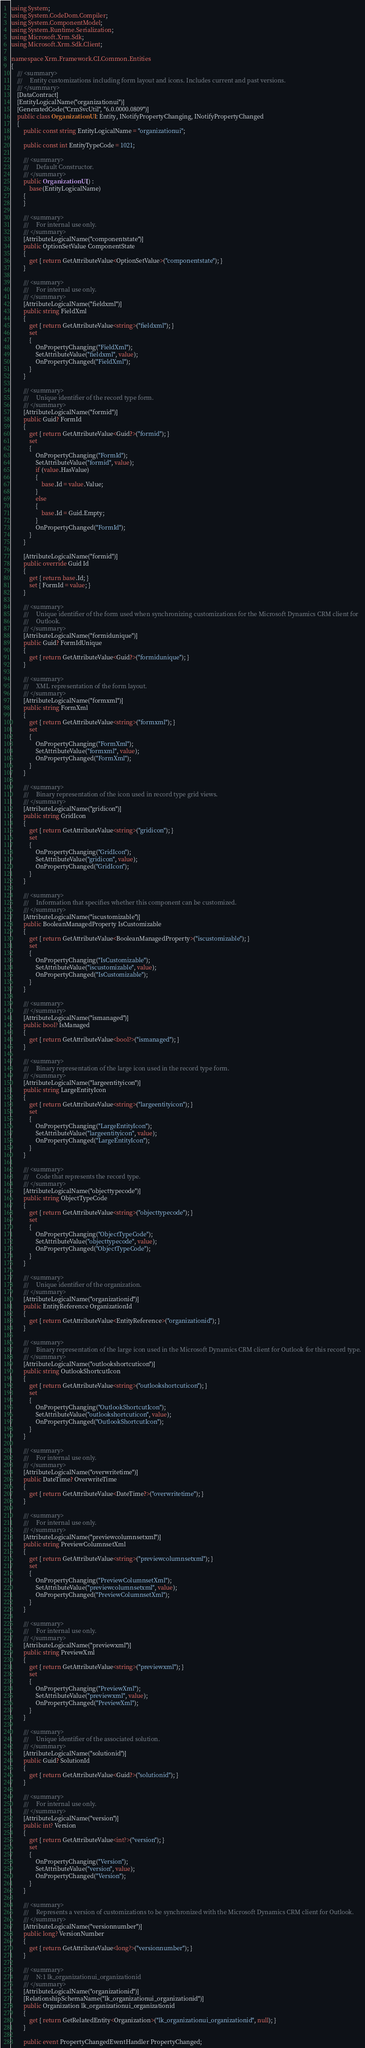<code> <loc_0><loc_0><loc_500><loc_500><_C#_>using System;
using System.CodeDom.Compiler;
using System.ComponentModel;
using System.Runtime.Serialization;
using Microsoft.Xrm.Sdk;
using Microsoft.Xrm.Sdk.Client;

namespace Xrm.Framework.CI.Common.Entities
{
    /// <summary>
    ///     Entity customizations including form layout and icons. Includes current and past versions.
    /// </summary>
    [DataContract]
    [EntityLogicalName("organizationui")]
    [GeneratedCode("CrmSvcUtil", "6.0.0000.0809")]
    public class OrganizationUI : Entity, INotifyPropertyChanging, INotifyPropertyChanged
    {
        public const string EntityLogicalName = "organizationui";

        public const int EntityTypeCode = 1021;

        /// <summary>
        ///     Default Constructor.
        /// </summary>
        public OrganizationUI() :
            base(EntityLogicalName)
        {
        }

        /// <summary>
        ///     For internal use only.
        /// </summary>
        [AttributeLogicalName("componentstate")]
        public OptionSetValue ComponentState
        {
            get { return GetAttributeValue<OptionSetValue>("componentstate"); }
        }

        /// <summary>
        ///     For internal use only.
        /// </summary>
        [AttributeLogicalName("fieldxml")]
        public string FieldXml
        {
            get { return GetAttributeValue<string>("fieldxml"); }
            set
            {
                OnPropertyChanging("FieldXml");
                SetAttributeValue("fieldxml", value);
                OnPropertyChanged("FieldXml");
            }
        }

        /// <summary>
        ///     Unique identifier of the record type form.
        /// </summary>
        [AttributeLogicalName("formid")]
        public Guid? FormId
        {
            get { return GetAttributeValue<Guid?>("formid"); }
            set
            {
                OnPropertyChanging("FormId");
                SetAttributeValue("formid", value);
                if (value.HasValue)
                {
                    base.Id = value.Value;
                }
                else
                {
                    base.Id = Guid.Empty;
                }
                OnPropertyChanged("FormId");
            }
        }

        [AttributeLogicalName("formid")]
        public override Guid Id
        {
            get { return base.Id; }
            set { FormId = value; }
        }

        /// <summary>
        ///     Unique identifier of the form used when synchronizing customizations for the Microsoft Dynamics CRM client for
        ///     Outlook.
        /// </summary>
        [AttributeLogicalName("formidunique")]
        public Guid? FormIdUnique
        {
            get { return GetAttributeValue<Guid?>("formidunique"); }
        }

        /// <summary>
        ///     XML representation of the form layout.
        /// </summary>
        [AttributeLogicalName("formxml")]
        public string FormXml
        {
            get { return GetAttributeValue<string>("formxml"); }
            set
            {
                OnPropertyChanging("FormXml");
                SetAttributeValue("formxml", value);
                OnPropertyChanged("FormXml");
            }
        }

        /// <summary>
        ///     Binary representation of the icon used in record type grid views.
        /// </summary>
        [AttributeLogicalName("gridicon")]
        public string GridIcon
        {
            get { return GetAttributeValue<string>("gridicon"); }
            set
            {
                OnPropertyChanging("GridIcon");
                SetAttributeValue("gridicon", value);
                OnPropertyChanged("GridIcon");
            }
        }

        /// <summary>
        ///     Information that specifies whether this component can be customized.
        /// </summary>
        [AttributeLogicalName("iscustomizable")]
        public BooleanManagedProperty IsCustomizable
        {
            get { return GetAttributeValue<BooleanManagedProperty>("iscustomizable"); }
            set
            {
                OnPropertyChanging("IsCustomizable");
                SetAttributeValue("iscustomizable", value);
                OnPropertyChanged("IsCustomizable");
            }
        }

        /// <summary>
        /// </summary>
        [AttributeLogicalName("ismanaged")]
        public bool? IsManaged
        {
            get { return GetAttributeValue<bool?>("ismanaged"); }
        }

        /// <summary>
        ///     Binary representation of the large icon used in the record type form.
        /// </summary>
        [AttributeLogicalName("largeentityicon")]
        public string LargeEntityIcon
        {
            get { return GetAttributeValue<string>("largeentityicon"); }
            set
            {
                OnPropertyChanging("LargeEntityIcon");
                SetAttributeValue("largeentityicon", value);
                OnPropertyChanged("LargeEntityIcon");
            }
        }

        /// <summary>
        ///     Code that represents the record type.
        /// </summary>
        [AttributeLogicalName("objecttypecode")]
        public string ObjectTypeCode
        {
            get { return GetAttributeValue<string>("objecttypecode"); }
            set
            {
                OnPropertyChanging("ObjectTypeCode");
                SetAttributeValue("objecttypecode", value);
                OnPropertyChanged("ObjectTypeCode");
            }
        }

        /// <summary>
        ///     Unique identifier of the organization.
        /// </summary>
        [AttributeLogicalName("organizationid")]
        public EntityReference OrganizationId
        {
            get { return GetAttributeValue<EntityReference>("organizationid"); }
        }

        /// <summary>
        ///     Binary representation of the large icon used in the Microsoft Dynamics CRM client for Outlook for this record type.
        /// </summary>
        [AttributeLogicalName("outlookshortcuticon")]
        public string OutlookShortcutIcon
        {
            get { return GetAttributeValue<string>("outlookshortcuticon"); }
            set
            {
                OnPropertyChanging("OutlookShortcutIcon");
                SetAttributeValue("outlookshortcuticon", value);
                OnPropertyChanged("OutlookShortcutIcon");
            }
        }

        /// <summary>
        ///     For internal use only.
        /// </summary>
        [AttributeLogicalName("overwritetime")]
        public DateTime? OverwriteTime
        {
            get { return GetAttributeValue<DateTime?>("overwritetime"); }
        }

        /// <summary>
        ///     For internal use only.
        /// </summary>
        [AttributeLogicalName("previewcolumnsetxml")]
        public string PreviewColumnsetXml
        {
            get { return GetAttributeValue<string>("previewcolumnsetxml"); }
            set
            {
                OnPropertyChanging("PreviewColumnsetXml");
                SetAttributeValue("previewcolumnsetxml", value);
                OnPropertyChanged("PreviewColumnsetXml");
            }
        }

        /// <summary>
        ///     For internal use only.
        /// </summary>
        [AttributeLogicalName("previewxml")]
        public string PreviewXml
        {
            get { return GetAttributeValue<string>("previewxml"); }
            set
            {
                OnPropertyChanging("PreviewXml");
                SetAttributeValue("previewxml", value);
                OnPropertyChanged("PreviewXml");
            }
        }

        /// <summary>
        ///     Unique identifier of the associated solution.
        /// </summary>
        [AttributeLogicalName("solutionid")]
        public Guid? SolutionId
        {
            get { return GetAttributeValue<Guid?>("solutionid"); }
        }

        /// <summary>
        ///     For internal use only.
        /// </summary>
        [AttributeLogicalName("version")]
        public int? Version
        {
            get { return GetAttributeValue<int?>("version"); }
            set
            {
                OnPropertyChanging("Version");
                SetAttributeValue("version", value);
                OnPropertyChanged("Version");
            }
        }

        /// <summary>
        ///     Represents a version of customizations to be synchronized with the Microsoft Dynamics CRM client for Outlook.
        /// </summary>
        [AttributeLogicalName("versionnumber")]
        public long? VersionNumber
        {
            get { return GetAttributeValue<long?>("versionnumber"); }
        }

        /// <summary>
        ///     N:1 lk_organizationui_organizationid
        /// </summary>
        [AttributeLogicalName("organizationid")]
        [RelationshipSchemaName("lk_organizationui_organizationid")]
        public Organization lk_organizationui_organizationid
        {
            get { return GetRelatedEntity<Organization>("lk_organizationui_organizationid", null); }
        }

        public event PropertyChangedEventHandler PropertyChanged;
</code> 